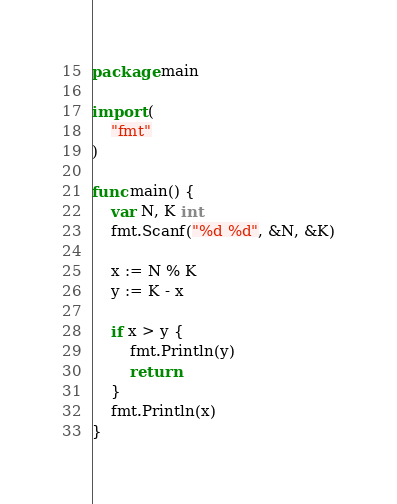Convert code to text. <code><loc_0><loc_0><loc_500><loc_500><_Go_>package main

import (
	"fmt"
)

func main() {
	var N, K int
	fmt.Scanf("%d %d", &N, &K)

	x := N % K
	y := K - x

	if x > y {
		fmt.Println(y)
		return
	}
	fmt.Println(x)
}
</code> 